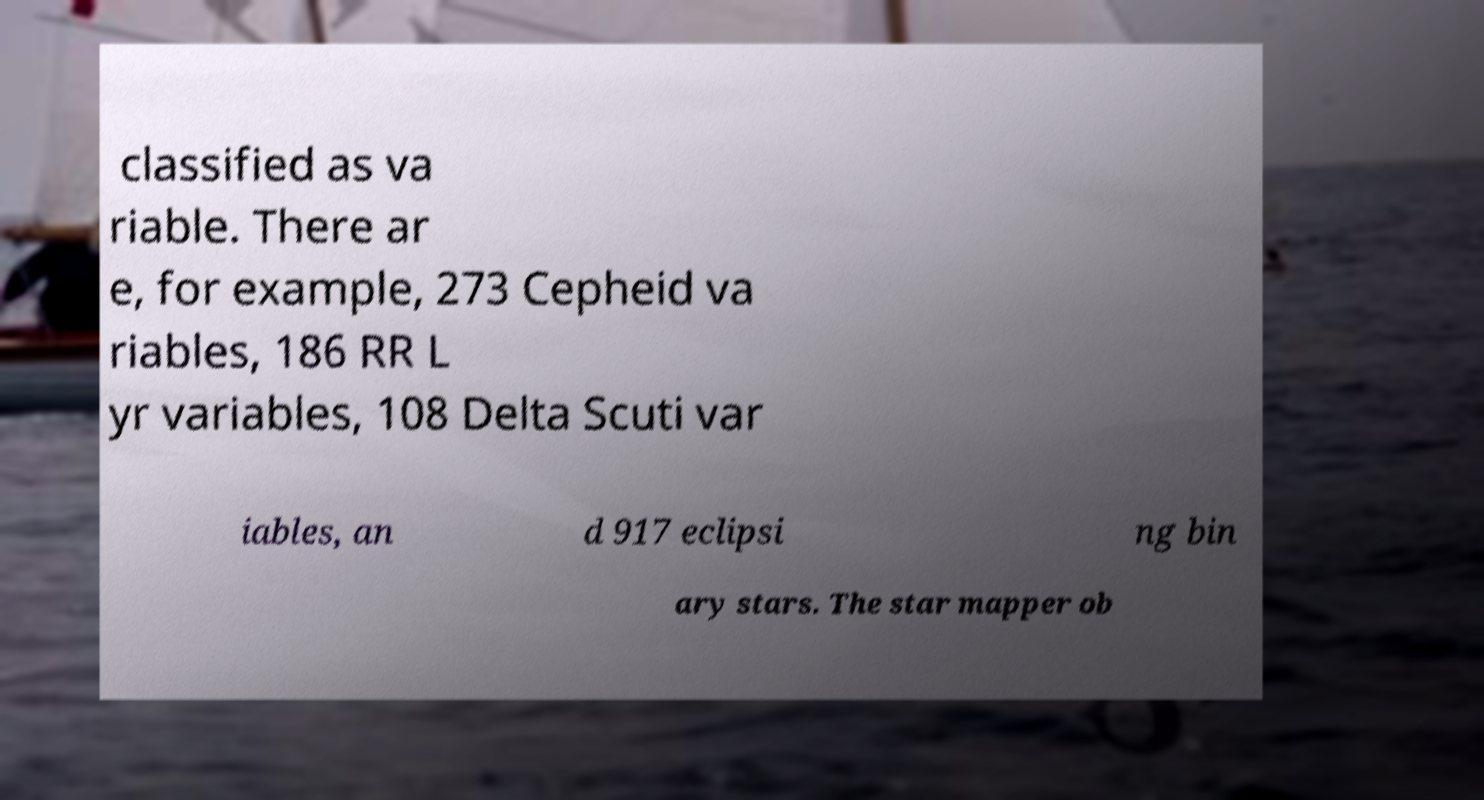Could you assist in decoding the text presented in this image and type it out clearly? classified as va riable. There ar e, for example, 273 Cepheid va riables, 186 RR L yr variables, 108 Delta Scuti var iables, an d 917 eclipsi ng bin ary stars. The star mapper ob 